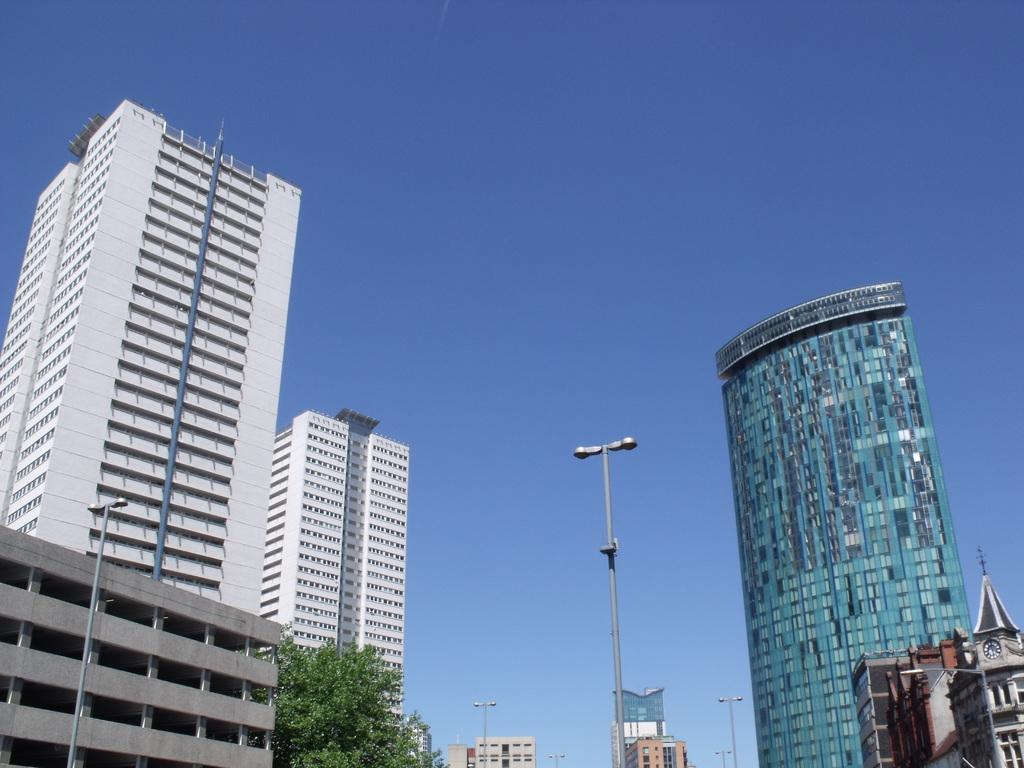What type of structures can be seen in the image? There are buildings in the image. What type of vegetation is present in the image? There are trees in the image. What type of rock can be seen being crushed by a machine in the image? There is no rock or machine present in the image. What type of crushing machine is visible in the image? There is no crushing machine present in the image. 